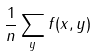<formula> <loc_0><loc_0><loc_500><loc_500>\frac { 1 } { n } \sum _ { y } f ( x , y )</formula> 